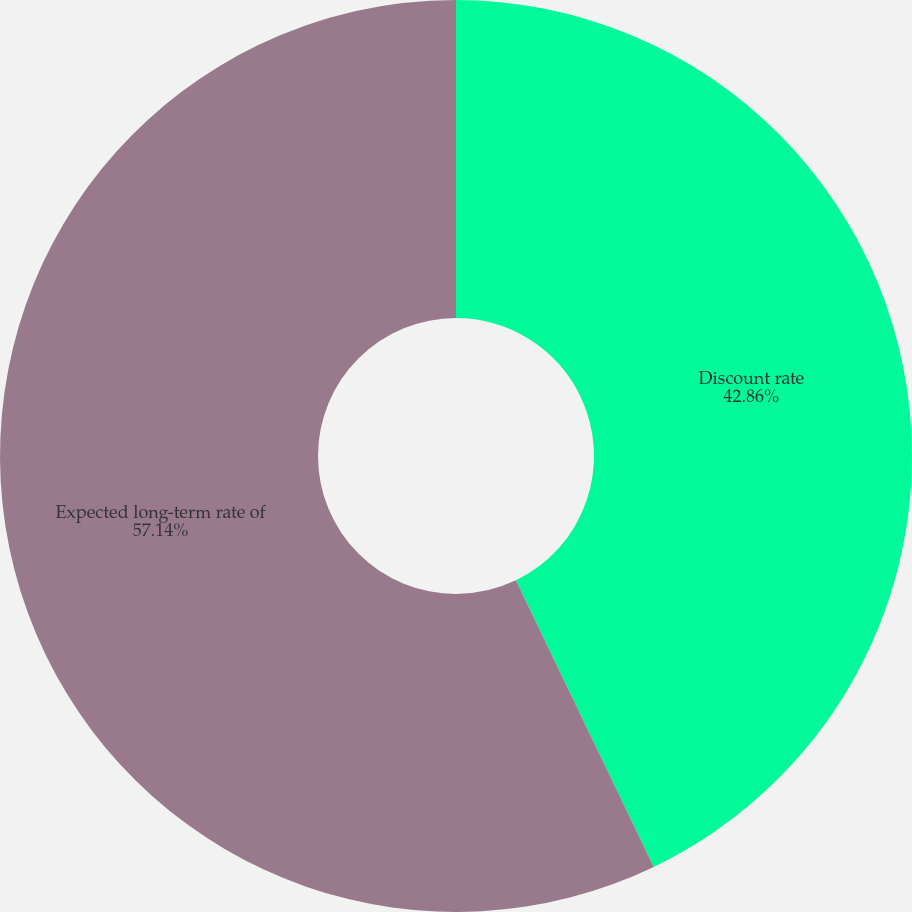<chart> <loc_0><loc_0><loc_500><loc_500><pie_chart><fcel>Discount rate<fcel>Expected long-term rate of<nl><fcel>42.86%<fcel>57.14%<nl></chart> 